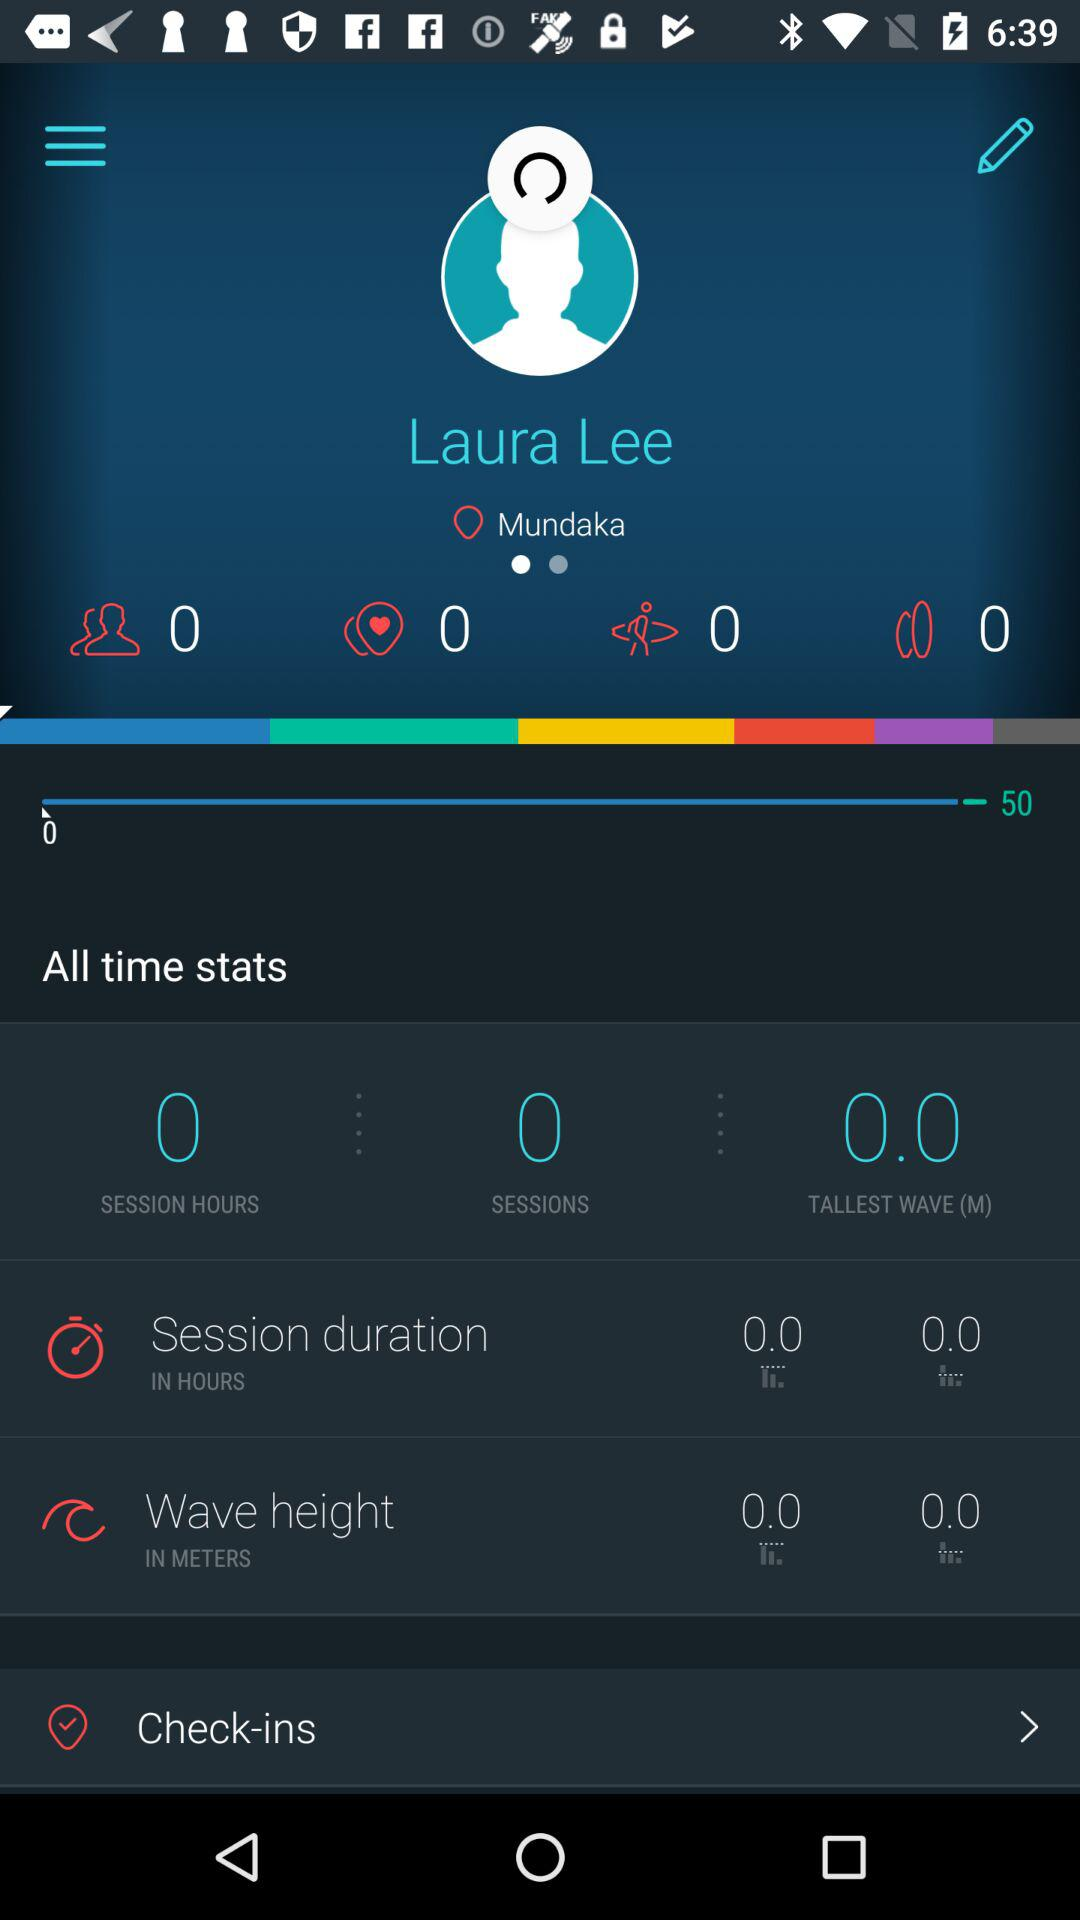How old is the user?
When the provided information is insufficient, respond with <no answer>. <no answer> 